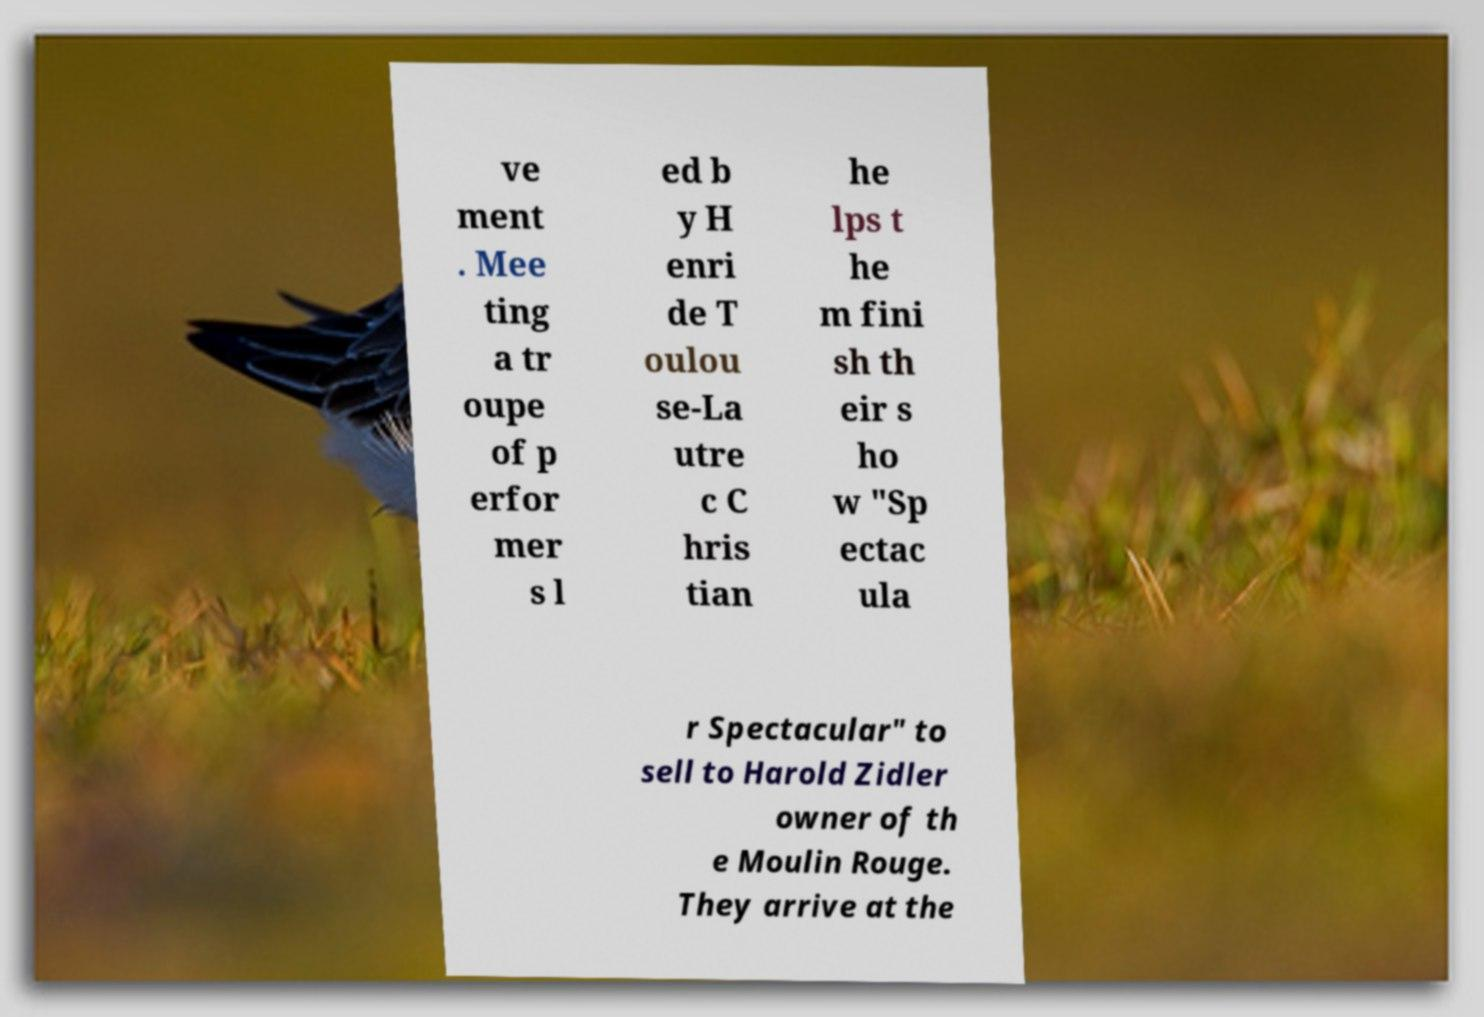For documentation purposes, I need the text within this image transcribed. Could you provide that? ve ment . Mee ting a tr oupe of p erfor mer s l ed b y H enri de T oulou se-La utre c C hris tian he lps t he m fini sh th eir s ho w "Sp ectac ula r Spectacular" to sell to Harold Zidler owner of th e Moulin Rouge. They arrive at the 